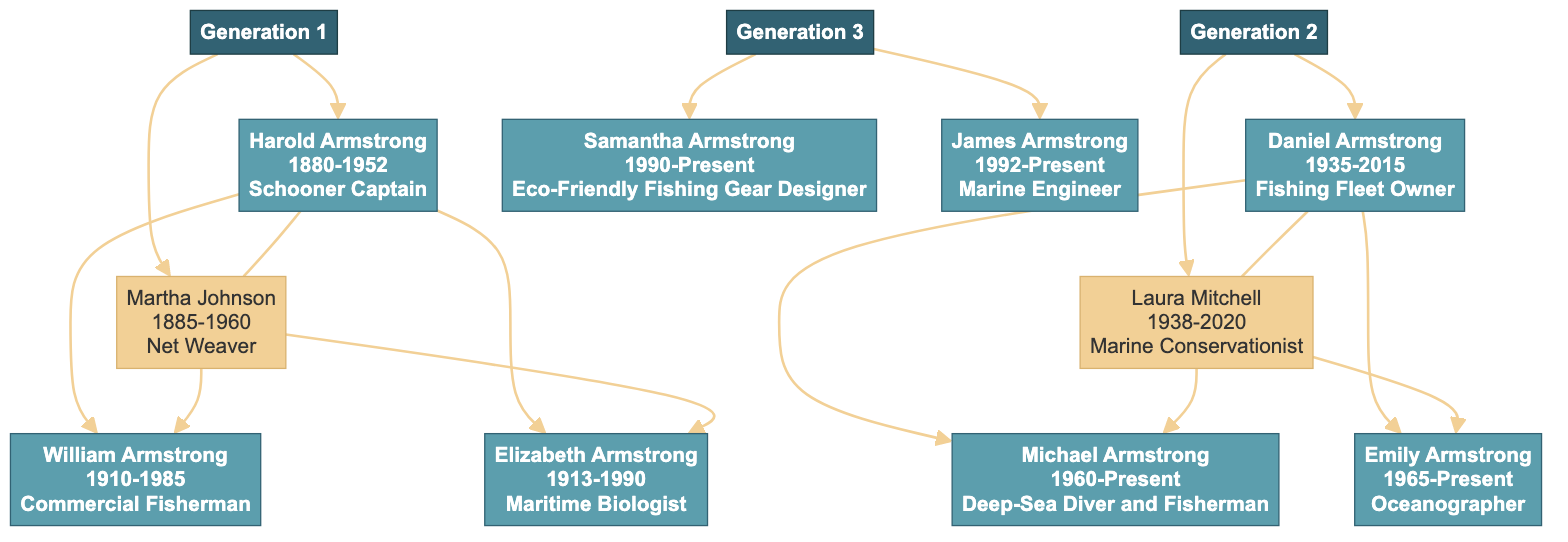What was Harold Armstrong's occupation? The diagram shows that Harold Armstrong was a Schooner Captain. This information can be directly found in the node representing him.
Answer: Schooner Captain Who is the spouse of Daniel Armstrong? Looking at the family tree, Daniel Armstrong is married to Laura Mitchell, as indicated by the connection between their nodes.
Answer: Laura Mitchell How many children did Harold and Martha Armstrong have? By examining the diagram, Harold and Martha Armstrong have two children listed: William and Elizabeth, which confirms that they had a total of two children.
Answer: 2 What was Elizabeth Armstrong's occupation? The diagram indicates Elizabeth Armstrong's occupation as a Maritime Biologist directly within her node, providing clear information about her profession.
Answer: Maritime Biologist Which generation does Samantha Armstrong belong to? The diagram categorizes Samantha Armstrong under Generation 3. This is evident from her position in the diagram as part of that generation's grouping.
Answer: 3 What significant achievement did William Armstrong make? According to the information presented in the diagram, William Armstrong is noted for introducing sustainable fishing methods, which is stated in the achievements section of his node.
Answer: Introduced sustainable fishing methods Who discovered an underwater cave network? The diagram shows that Michael Armstrong is the one who discovered an underwater cave network, as stated in the stories associated with him.
Answer: Michael Armstrong What year did Daniel Armstrong pass away? By checking the lifespans provided in the diagram, one can see that Daniel Armstrong passed away in the year 2015, as noted next to his name.
Answer: 2015 How many generations are represented in this family tree? The diagram clearly shows three generations represented: Generation 1, Generation 2, and Generation 3, thus indicating that there are a total of three generations.
Answer: 3 